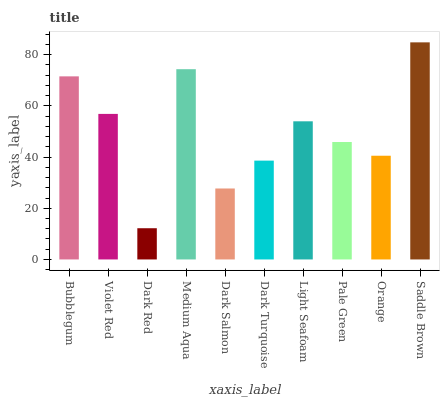Is Dark Red the minimum?
Answer yes or no. Yes. Is Saddle Brown the maximum?
Answer yes or no. Yes. Is Violet Red the minimum?
Answer yes or no. No. Is Violet Red the maximum?
Answer yes or no. No. Is Bubblegum greater than Violet Red?
Answer yes or no. Yes. Is Violet Red less than Bubblegum?
Answer yes or no. Yes. Is Violet Red greater than Bubblegum?
Answer yes or no. No. Is Bubblegum less than Violet Red?
Answer yes or no. No. Is Light Seafoam the high median?
Answer yes or no. Yes. Is Pale Green the low median?
Answer yes or no. Yes. Is Medium Aqua the high median?
Answer yes or no. No. Is Dark Red the low median?
Answer yes or no. No. 